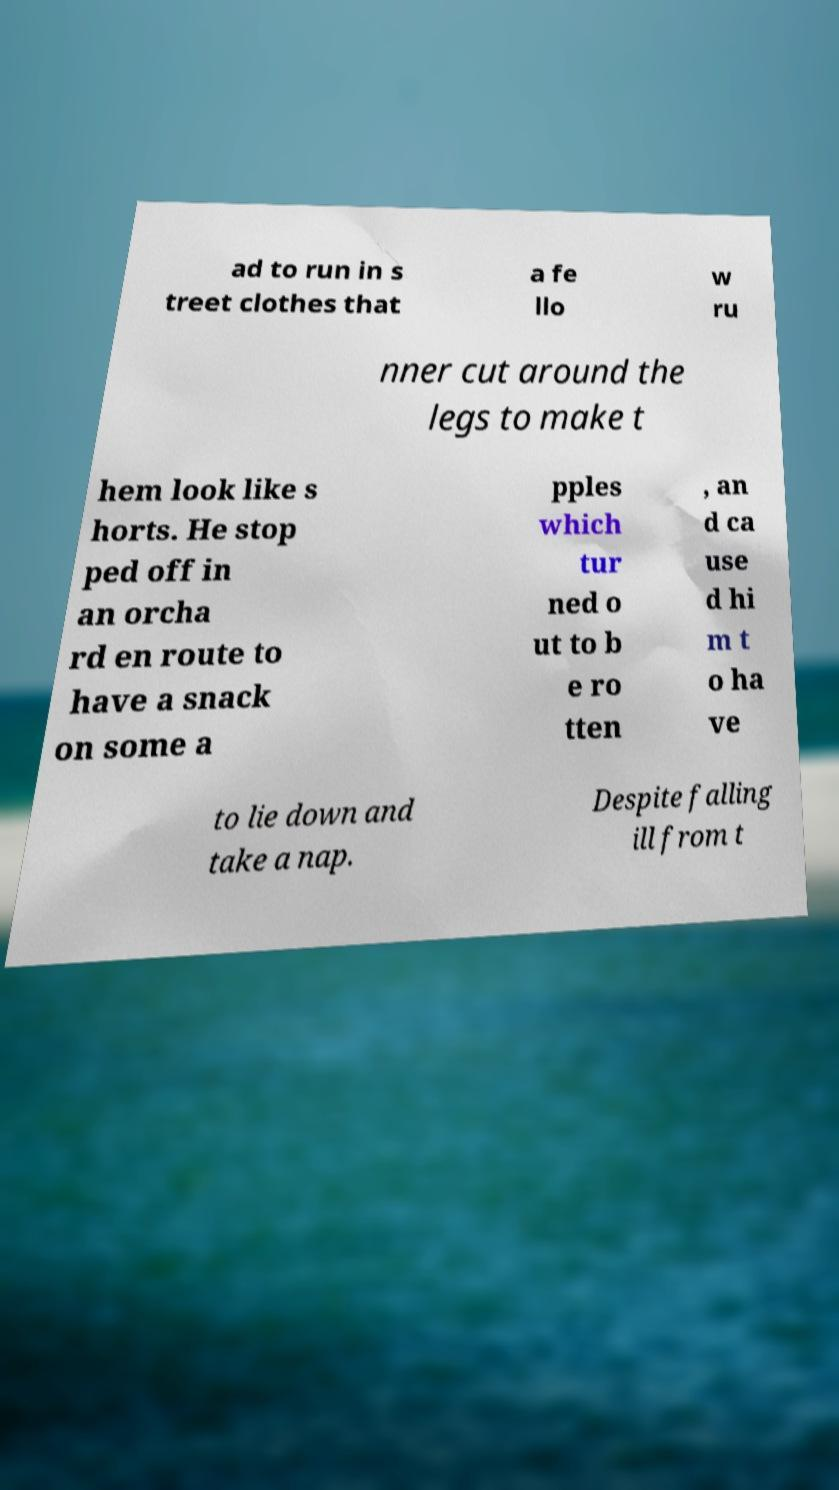Please identify and transcribe the text found in this image. ad to run in s treet clothes that a fe llo w ru nner cut around the legs to make t hem look like s horts. He stop ped off in an orcha rd en route to have a snack on some a pples which tur ned o ut to b e ro tten , an d ca use d hi m t o ha ve to lie down and take a nap. Despite falling ill from t 